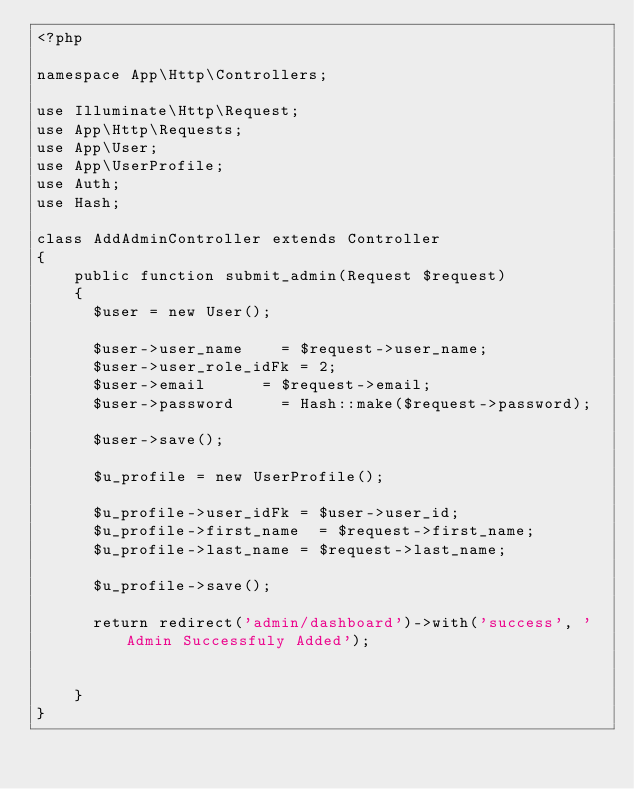Convert code to text. <code><loc_0><loc_0><loc_500><loc_500><_PHP_><?php

namespace App\Http\Controllers;

use Illuminate\Http\Request;
use App\Http\Requests;
use App\User;
use App\UserProfile;
use Auth;
use Hash;

class AddAdminController extends Controller
{
    public function submit_admin(Request $request)
    {
    	$user = new User();

    	$user->user_name		= $request->user_name;
    	$user->user_role_idFk	= 2;
    	$user->email 			= $request->email;
    	$user->password 		= Hash::make($request->password);

    	$user->save();

    	$u_profile = new UserProfile();

    	$u_profile->user_idFk	= $user->user_id;
    	$u_profile->first_name	= $request->first_name;
    	$u_profile->last_name	= $request->last_name;

    	$u_profile->save();

    	return redirect('admin/dashboard')->with('success', 'Admin Successfuly Added');


    }
}
</code> 